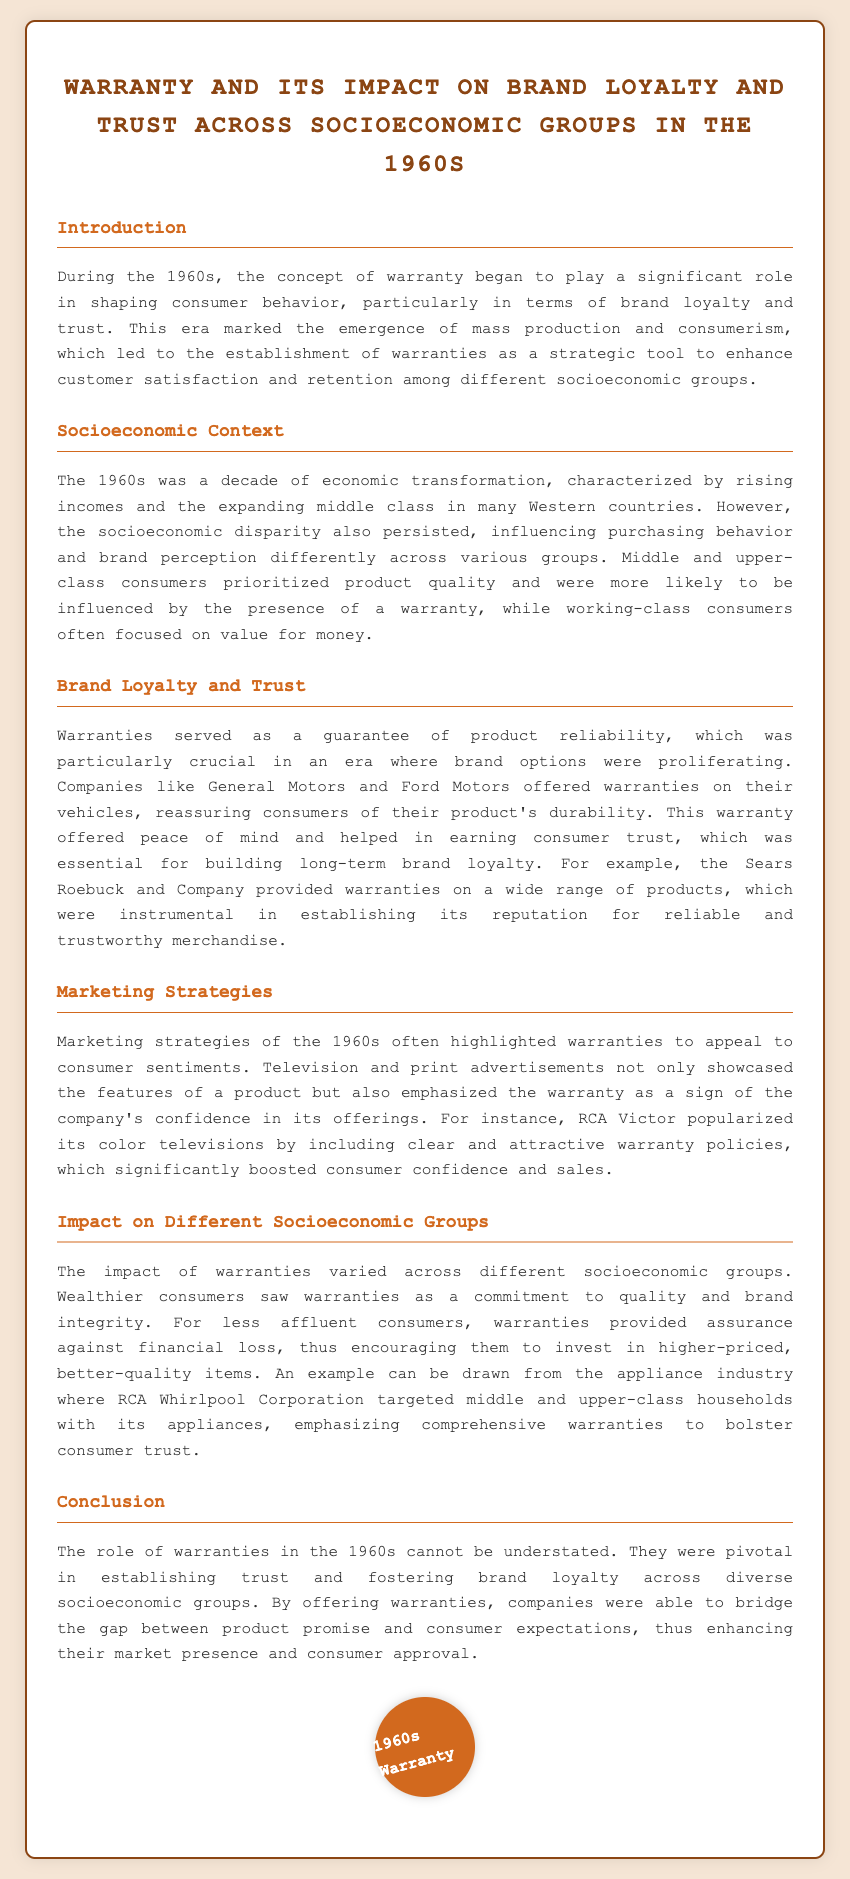what decade is focused on in the document? The document specifically discusses the role of warranties in the 1960s.
Answer: 1960s which company is mentioned for providing warranties on vehicles? General Motors and Ford Motors are noted for offering warranties on their vehicles, reassuring consumers of durability.
Answer: General Motors and Ford Motors what marketing strategy was highlighted to appeal to consumer sentiments? The marketing strategies of the 1960s emphasized the importance of warranties to enhance consumer confidence.
Answer: Warranties who was the targeted demographic for RCA Whirlpool Corporation's appliances? The document mentions that RCA Whirlpool Corporation targeted middle and upper-class households.
Answer: Middle and upper-class households how did wealthier consumers perceive warranties? Wealthier consumers viewed warranties as a commitment to quality and brand integrity.
Answer: Commitment to quality and brand integrity what was a critical factor for building brand loyalty according to the document? The document states that consumer trust was essential for building long-term brand loyalty.
Answer: Consumer trust which company provided warranties on a wide range of products? Sears Roebuck and Company is mentioned as providing warranties on a variety of products.
Answer: Sears Roebuck and Company how did less affluent consumers view warranties? Warranties provided assurance against financial loss for less affluent consumers.
Answer: Assurance against financial loss what did RCA Victor popularize in their marketing efforts? RCA Victor included clear and attractive warranty policies in their marketing of color televisions.
Answer: Color televisions 